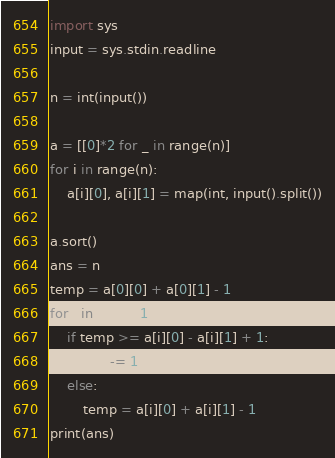Convert code to text. <code><loc_0><loc_0><loc_500><loc_500><_Python_>import sys
input = sys.stdin.readline

n = int(input())

a = [[0]*2 for _ in range(n)]
for i in range(n):
    a[i][0], a[i][1] = map(int, input().split())

a.sort()
ans = n
temp = a[0][0] + a[0][1] - 1
for i in range(1, n):
    if temp >= a[i][0] - a[i][1] + 1:
        ans -= 1
    else:
        temp = a[i][0] + a[i][1] - 1
print(ans)</code> 